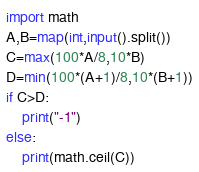Convert code to text. <code><loc_0><loc_0><loc_500><loc_500><_Python_>import math
A,B=map(int,input().split())
C=max(100*A/8,10*B)
D=min(100*(A+1)/8,10*(B+1))
if C>D:
    print("-1")
else:
    print(math.ceil(C))</code> 